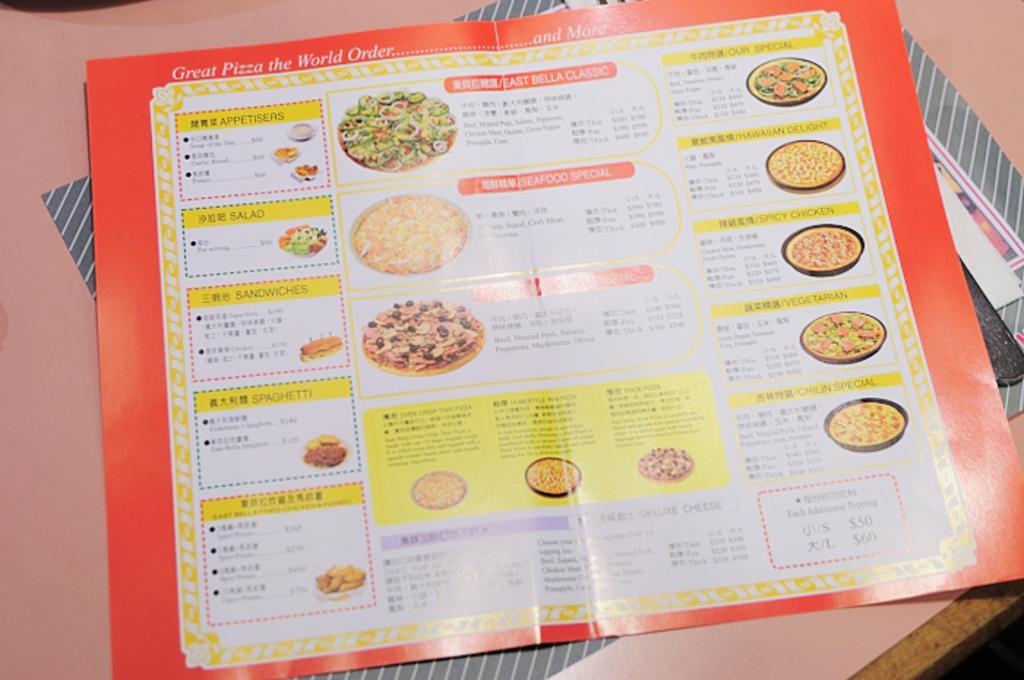Please provide a concise description of this image. In this image there is a menu card having few picture of food and some text on it. Behind the menu card there is paper on the table. 